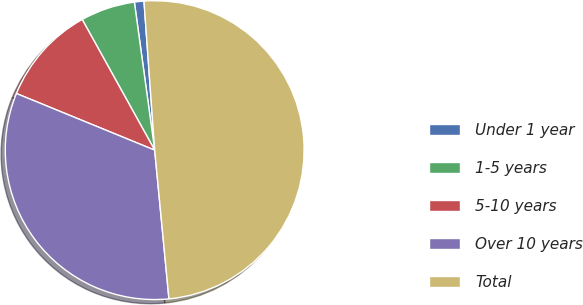Convert chart to OTSL. <chart><loc_0><loc_0><loc_500><loc_500><pie_chart><fcel>Under 1 year<fcel>1-5 years<fcel>5-10 years<fcel>Over 10 years<fcel>Total<nl><fcel>1.03%<fcel>5.89%<fcel>10.75%<fcel>32.71%<fcel>49.62%<nl></chart> 